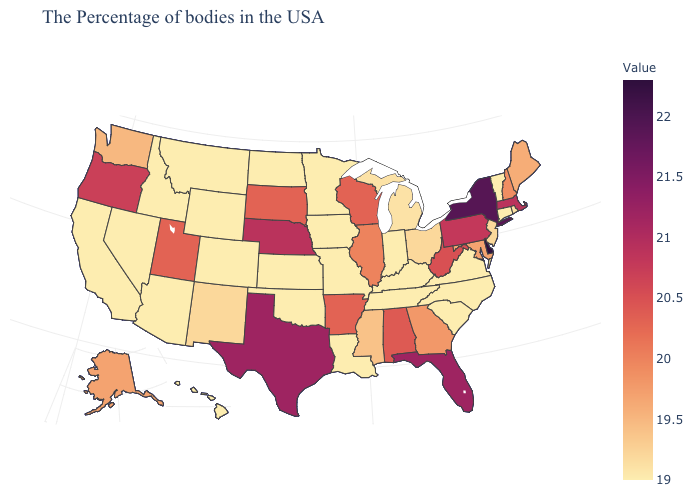Does Maryland have a higher value than New Jersey?
Quick response, please. Yes. Does Maine have a lower value than Michigan?
Concise answer only. No. Does West Virginia have the highest value in the South?
Answer briefly. No. 